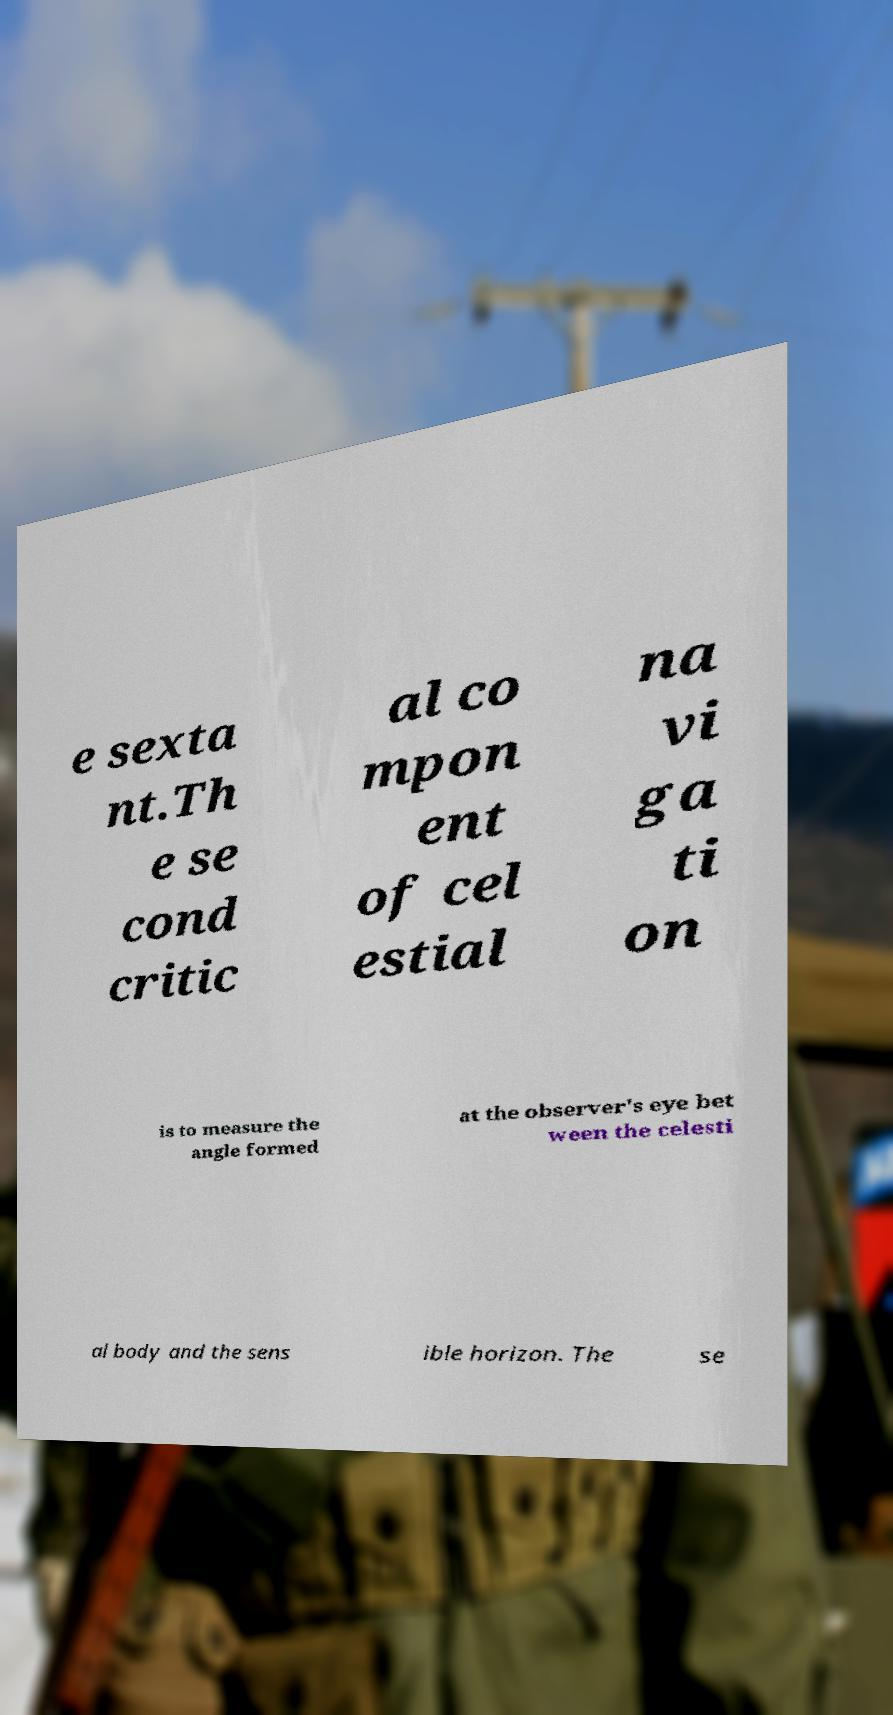Can you accurately transcribe the text from the provided image for me? e sexta nt.Th e se cond critic al co mpon ent of cel estial na vi ga ti on is to measure the angle formed at the observer's eye bet ween the celesti al body and the sens ible horizon. The se 